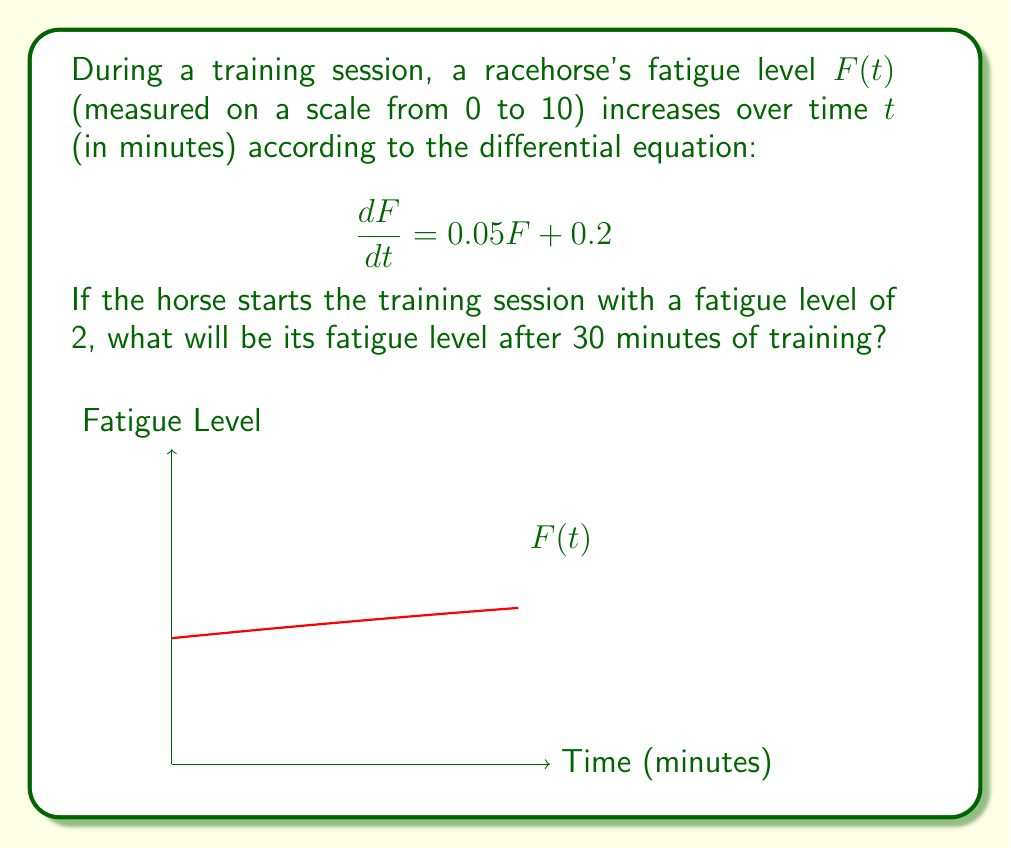Give your solution to this math problem. Let's solve this step-by-step:

1) We have the differential equation: $\frac{dF}{dt} = 0.05F + 0.2$

2) This is a linear first-order differential equation of the form $\frac{dy}{dx} + P(x)y = Q(x)$, where $P(x) = -0.05$ and $Q(x) = 0.2$

3) The general solution for this type of equation is:
   $y = e^{-\int P(x)dx}(\int Q(x)e^{\int P(x)dx}dx + C)$

4) In our case:
   $F = e^{0.05t}(\int 0.2e^{-0.05t}dt + C)$

5) Solving the integral:
   $F = e^{0.05t}(-4e^{-0.05t} + C)$
   $F = -4 + Ce^{0.05t}$

6) We're given the initial condition $F(0) = 2$. Let's use this to find C:
   $2 = -4 + C$
   $C = 6$

7) So our particular solution is:
   $F(t) = -4 + 6e^{0.05t}$

8) Now we can find F(30):
   $F(30) = -4 + 6e^{0.05(30)}$
   $F(30) = -4 + 6e^{1.5}$
   $F(30) \approx 3.97$
Answer: $F(30) \approx 3.97$ 